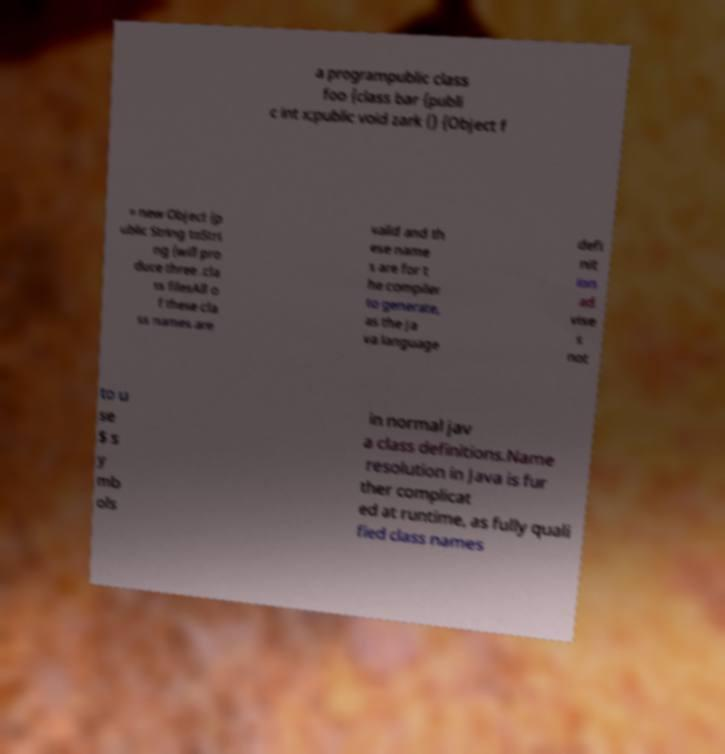Can you read and provide the text displayed in the image?This photo seems to have some interesting text. Can you extract and type it out for me? a programpublic class foo {class bar {publi c int x;public void zark () {Object f = new Object {p ublic String toStri ng {will pro duce three .cla ss filesAll o f these cla ss names are valid and th ese name s are for t he compiler to generate, as the Ja va language defi nit ion ad vise s not to u se $ s y mb ols in normal jav a class definitions.Name resolution in Java is fur ther complicat ed at runtime, as fully quali fied class names 